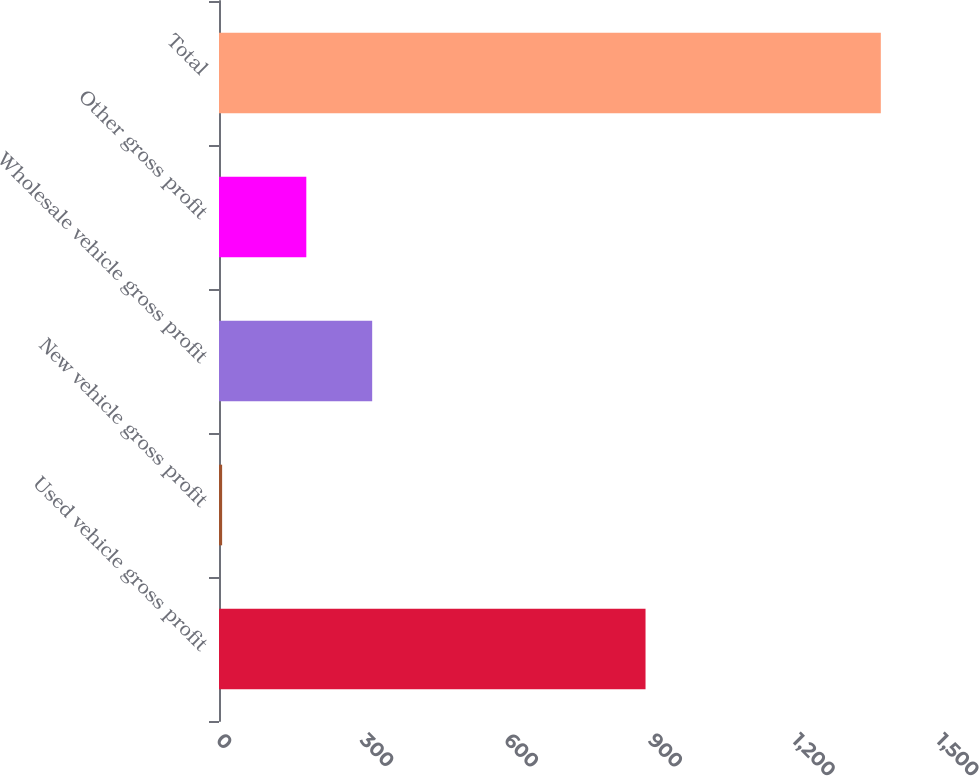Convert chart. <chart><loc_0><loc_0><loc_500><loc_500><bar_chart><fcel>Used vehicle gross profit<fcel>New vehicle gross profit<fcel>Wholesale vehicle gross profit<fcel>Other gross profit<fcel>Total<nl><fcel>888.6<fcel>6.5<fcel>319.13<fcel>181.9<fcel>1378.8<nl></chart> 